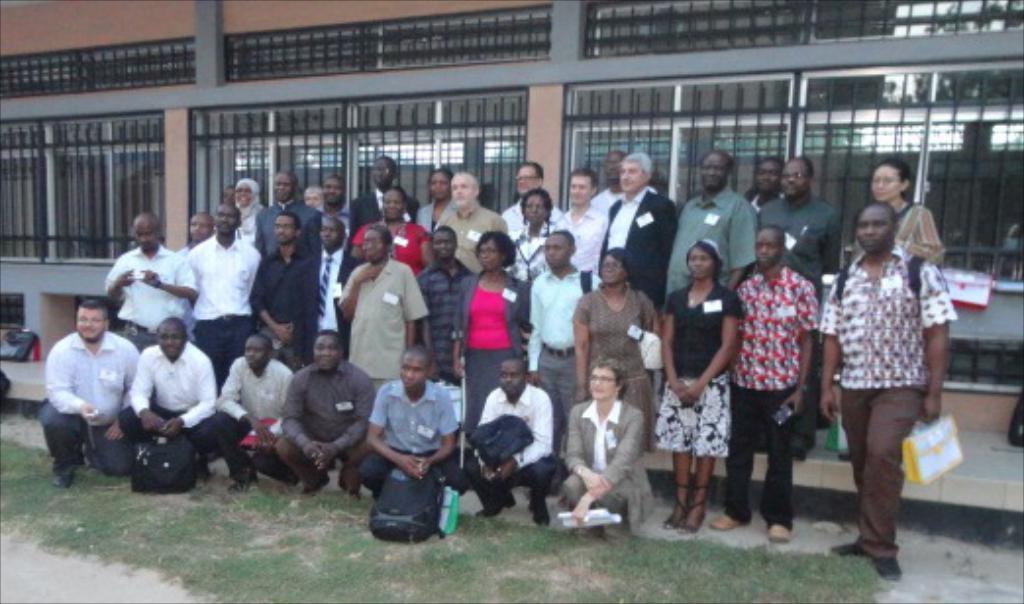Could you give a brief overview of what you see in this image? In the center of the image we can see a few people are in different costumes. Among them, we can see a few people are holding some objects. At the bottom of the image, we can see the grass. In the background there is a building and a few other objects. 